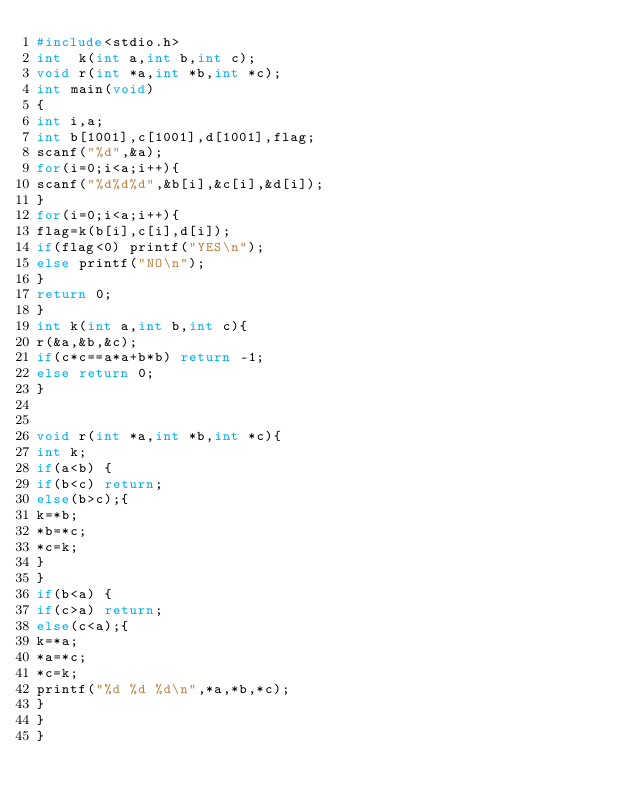<code> <loc_0><loc_0><loc_500><loc_500><_C_>#include<stdio.h>
int  k(int a,int b,int c);
void r(int *a,int *b,int *c);
int main(void)
{
int i,a;
int b[1001],c[1001],d[1001],flag;
scanf("%d",&a);
for(i=0;i<a;i++){
scanf("%d%d%d",&b[i],&c[i],&d[i]);
}
for(i=0;i<a;i++){
flag=k(b[i],c[i],d[i]);
if(flag<0) printf("YES\n");
else printf("NO\n");
}
return 0;
}
int k(int a,int b,int c){
r(&a,&b,&c);
if(c*c==a*a+b*b) return -1;
else return 0;
}


void r(int *a,int *b,int *c){
int k;
if(a<b) {
if(b<c) return;
else(b>c);{
k=*b;
*b=*c;
*c=k;
}
}
if(b<a) {
if(c>a) return;
else(c<a);{
k=*a;
*a=*c;
*c=k;
printf("%d %d %d\n",*a,*b,*c);
}
}
}</code> 